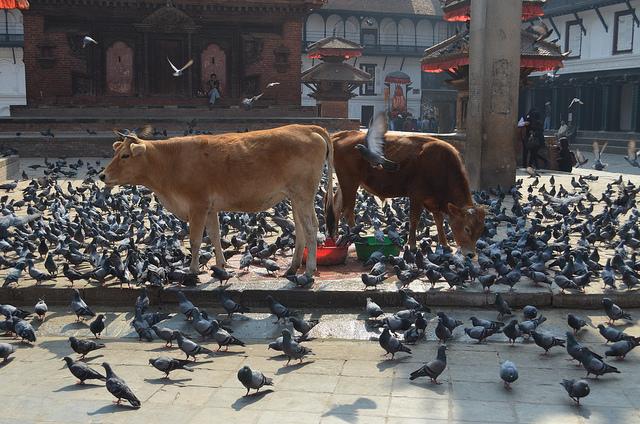Are the birds frightened of the cows?
Be succinct. No. Are the cows planning to eat the pigeons?
Keep it brief. No. Is the cow eating?
Quick response, please. Yes. Would this likely be seen in an American city center?
Concise answer only. No. Are the cows the same color?
Keep it brief. No. 